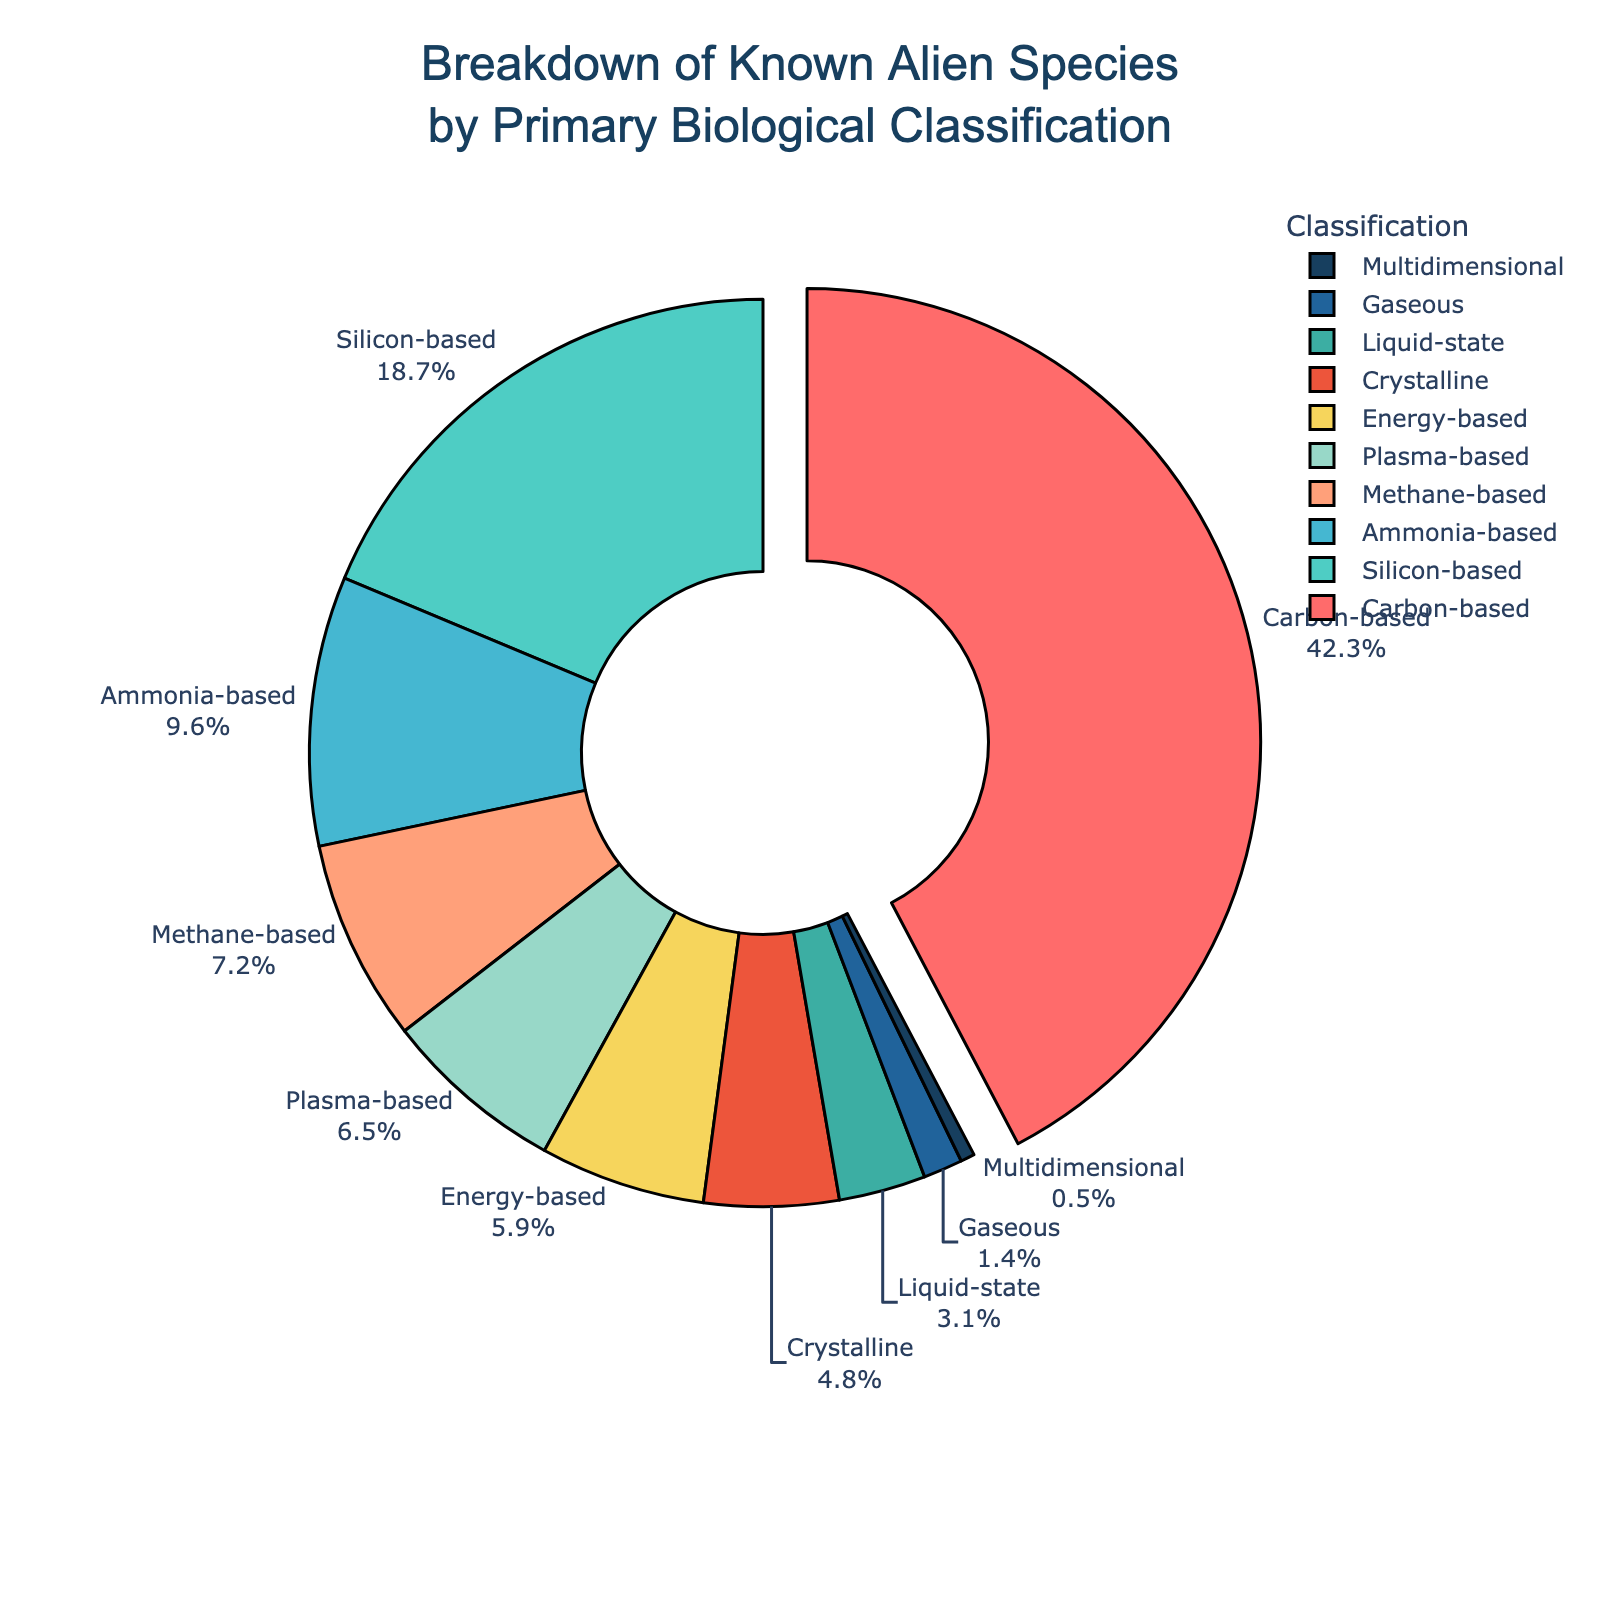How many classifications make up more than 10% of the known alien species? We need to identify classifications with percentages above 10%. From the data: Carbon-based (42.3%), and Silicon-based (18.7%) are above 10%. So there are 2 classifications above 10%.
Answer: 2 Which classification has the highest percentage and what is its value? By looking at the pie chart, we can see that Carbon-based species have the highest percentage. The value is 42.3%.
Answer: Carbon-based, 42.3% Compare the percentages of Ammonia-based and Methane-based classifications. Which one is greater and by how much? Ammonia-based has 9.6% and Methane-based has 7.2%. The difference is 9.6% - 7.2% = 2.4%. Ammonia-based is greater by 2.4%.
Answer: Ammonia-based, 2.4% What is the combined percentage of Liquid-state and Gaseous classifications? The Liquid-state classification is 3.1% and the Gaseous classification is 1.4%. Their combined percentage is 3.1% + 1.4% = 4.5%.
Answer: 4.5% Which classifications are represented by colors near the blue spectrum and what are their percentages? Referring to the likely color assignments: Silicon-based (cyan, 18.7%), Liquid-state (blue-green, 3.1%), and Gaseous (blue, 1.4%) are near the blue spectrum.
Answer: Silicon-based (18.7%), Liquid-state (3.1%), Gaseous (1.4%) How much larger is the percentage of Carbon-based species compared to the Energy-based species? Carbon-based species are 42.3%, and Energy-based are 5.9%. The difference is 42.3% - 5.9% = 36.4%.
Answer: 36.4% If we combine the percentages of Crystalline and Plasma-based classifications, will it exceed that of Ammonia-based classification? Crystalline is 4.8% and Plasma-based is 6.5%. Their combined percentage is 4.8% + 6.5% = 11.3%, which is greater than Ammonia-based at 9.6%.
Answer: Yes Which classification has the smallest percentage and what is its color in the pie chart? Multidimensional has the smallest percentage at 0.5%. It is likely colored dark blue or near-dark blue.
Answer: Multidimensional, dark blue What is the difference in percentage between the classification with the second highest value and that with the lowest? The second highest percentage is Silicon-based at 18.7% and the lowest is Multidimensional at 0.5%. The difference is 18.7% - 0.5% = 18.2%.
Answer: 18.2% Which classifications have their labels pulled slightly away from the pie chart and why? Only the Carbon-based classification's label is pulled away from the pie chart. This is done to highlight that it has the highest percentage.
Answer: Carbon-based 